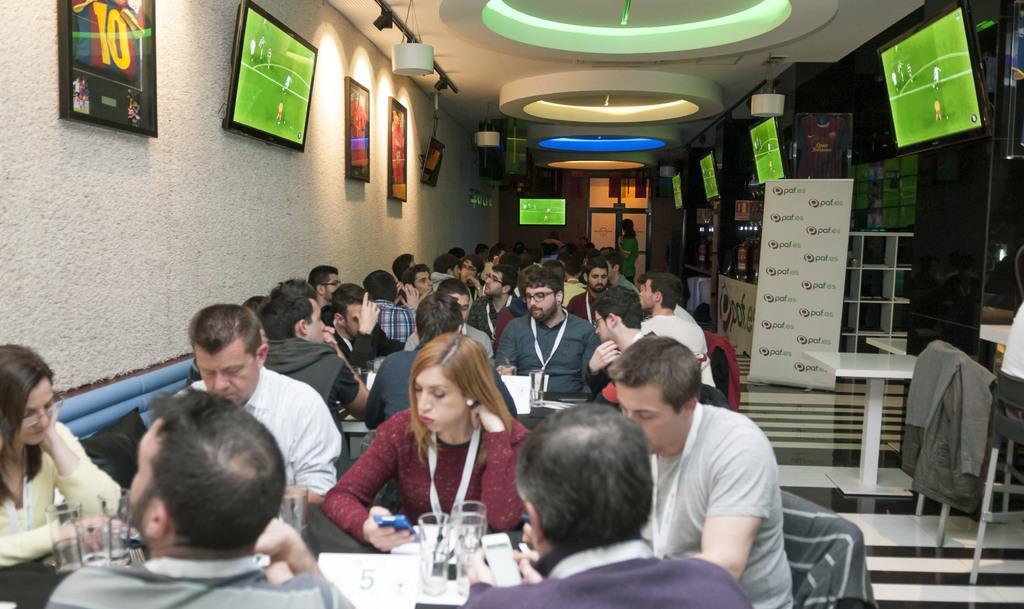Can you describe this image briefly? There are few people sitting in chairs and there is a table in front of them which has some objects on it and there are televisions on the either side of them. 